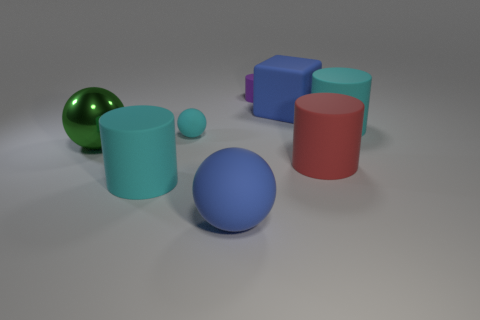Are there fewer cylinders that are left of the tiny purple matte cylinder than gray rubber blocks? Actually, it appears that there is an equal number of cylinders to the left of the tiny purple matte cylinder and gray rubber blocks in the image when comparing their quantities directly. 